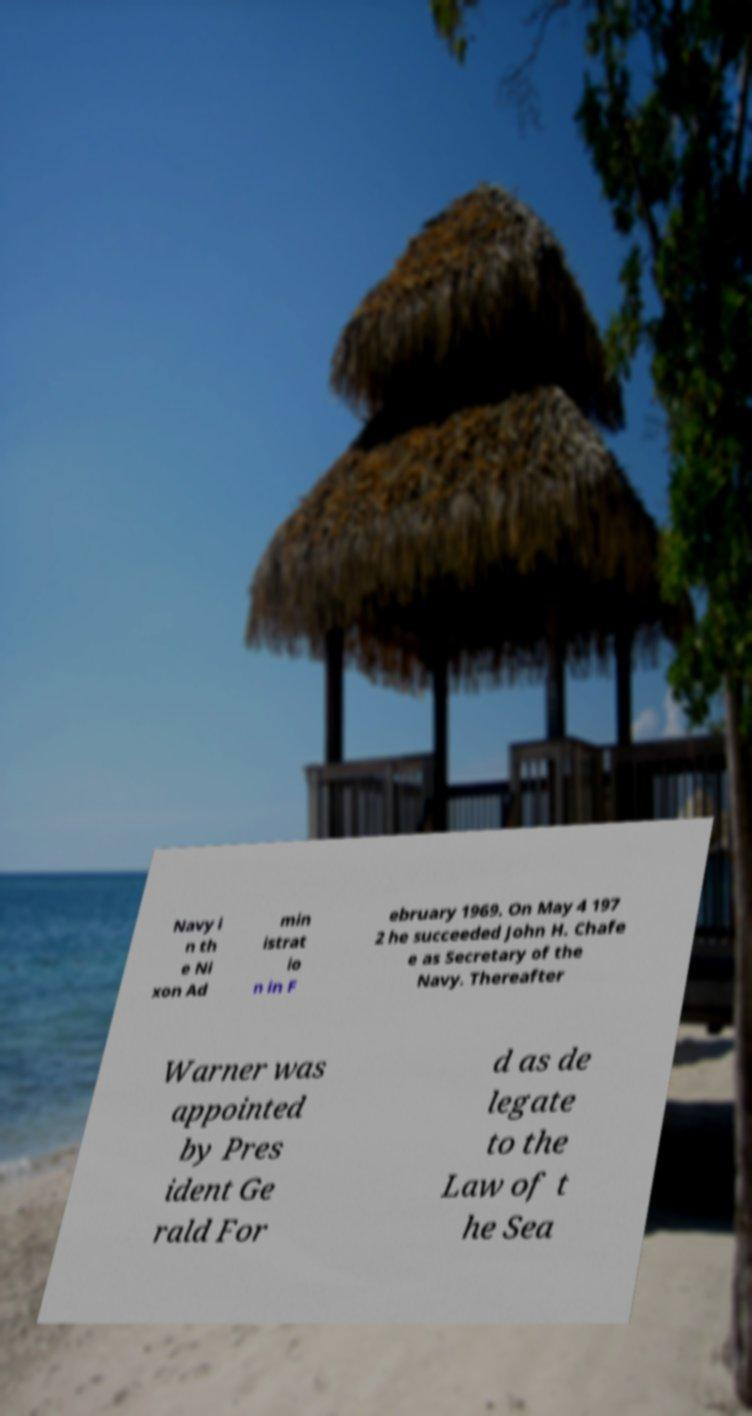For documentation purposes, I need the text within this image transcribed. Could you provide that? Navy i n th e Ni xon Ad min istrat io n in F ebruary 1969. On May 4 197 2 he succeeded John H. Chafe e as Secretary of the Navy. Thereafter Warner was appointed by Pres ident Ge rald For d as de legate to the Law of t he Sea 